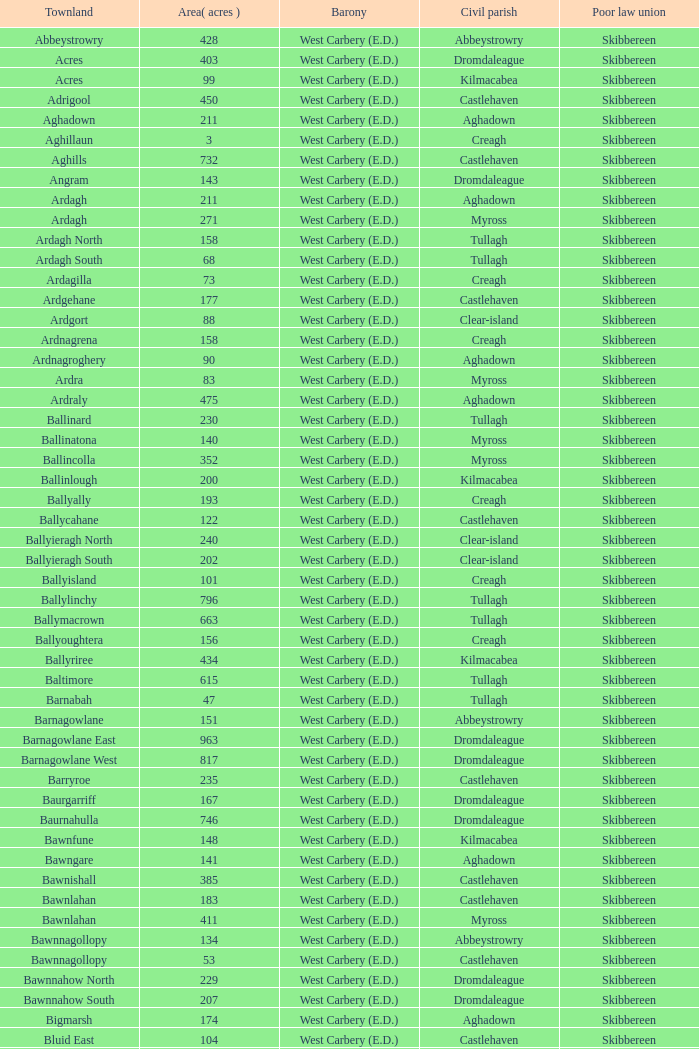What is the most extensive area when the poor law union is skibbereen and the civil parish is tullagh? 796.0. 